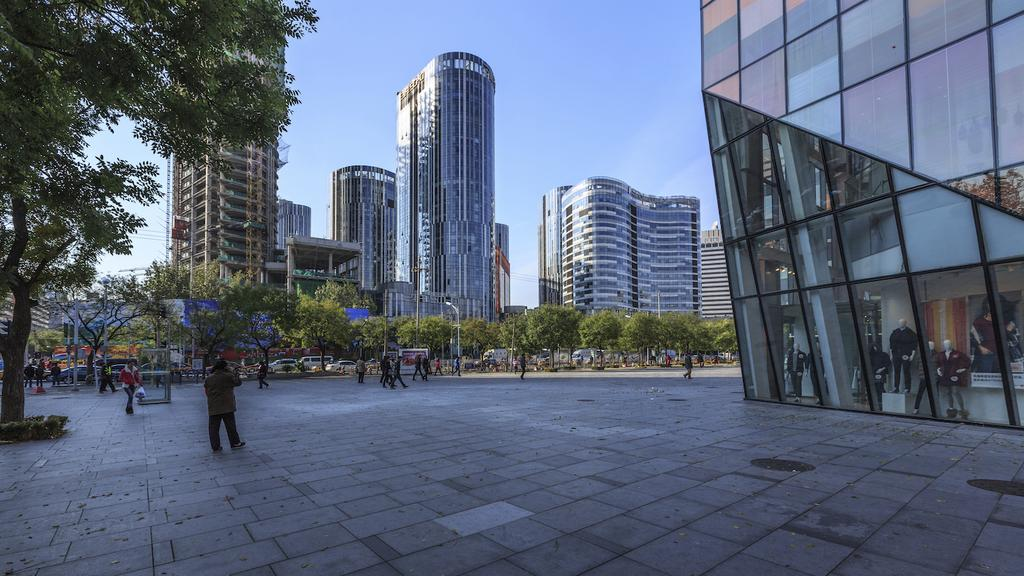Who or what can be seen in the image? There are people in the image. What type of structures are visible in the image? There are buildings in the image. What are the light poles used for in the image? Light poles are visible in the image, likely for providing illumination. What type of vegetation is present in the image? Trees are present in the image. What do the boards with text in the image convey? The boards with text in the image may convey information or advertisements. What are the mannequins used for in the image? Mannequins are in the image, likely for displaying clothing or other items. What is visible in the background of the image? The sky is visible in the image. How many stitches are required to fix the broken lock in the image? There is no broken lock present in the image, so the number of stitches required cannot be determined. What type of sleep aid is being advertised on the boards with text in the image? There is no sleep aid mentioned or advertised on the boards with text in the image. 